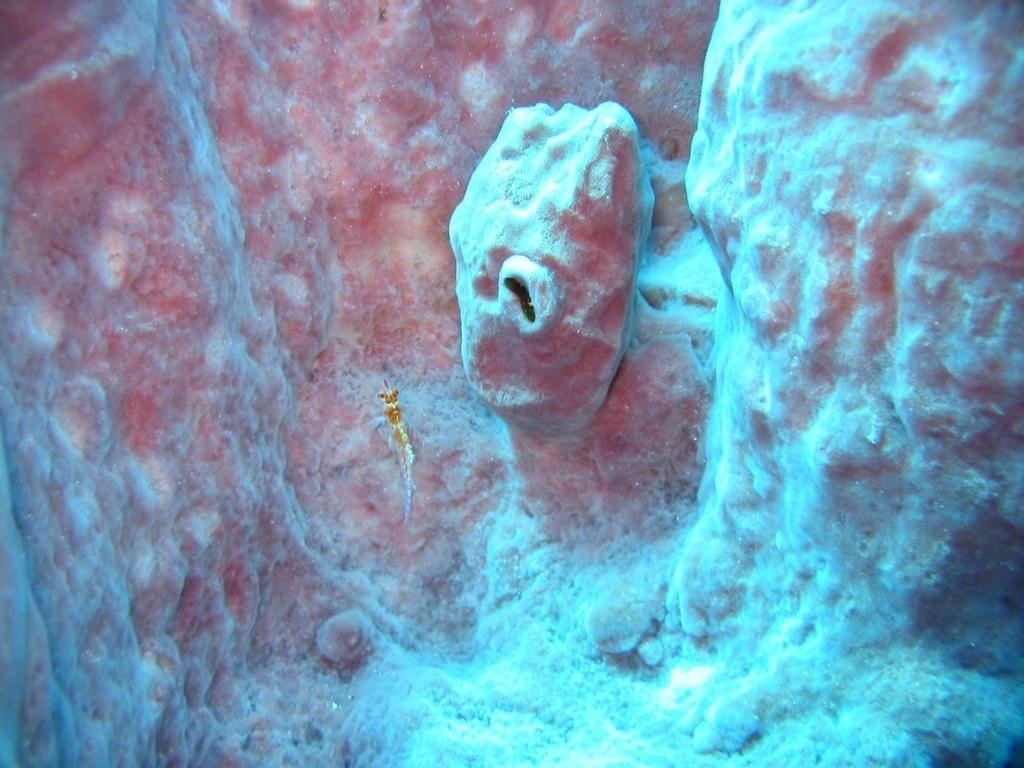What type of animal can be seen in the water in the image? There is a fish in the water in the image. What type of landscape feature is visible in the image? There are small hills visible in the image. What type of corn is growing on the mine in the image? There is no corn or mine present in the image; it features a fish in the water and small hills. 